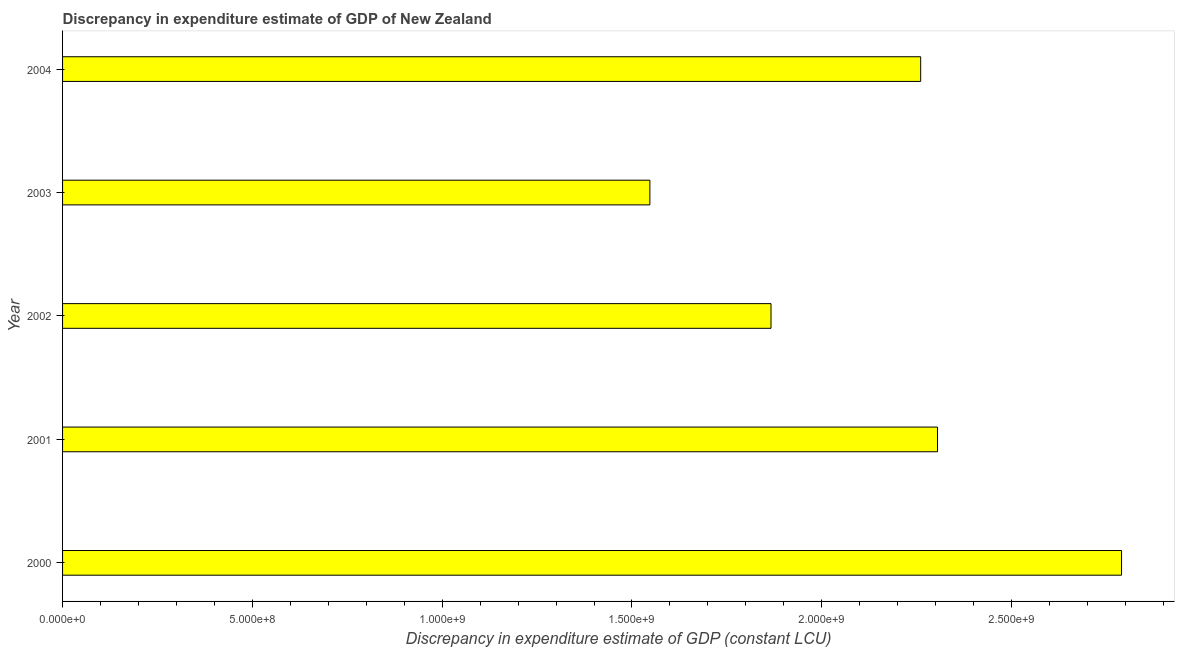Does the graph contain grids?
Make the answer very short. No. What is the title of the graph?
Your answer should be compact. Discrepancy in expenditure estimate of GDP of New Zealand. What is the label or title of the X-axis?
Ensure brevity in your answer.  Discrepancy in expenditure estimate of GDP (constant LCU). What is the label or title of the Y-axis?
Your answer should be very brief. Year. What is the discrepancy in expenditure estimate of gdp in 2001?
Offer a very short reply. 2.30e+09. Across all years, what is the maximum discrepancy in expenditure estimate of gdp?
Provide a succinct answer. 2.79e+09. Across all years, what is the minimum discrepancy in expenditure estimate of gdp?
Ensure brevity in your answer.  1.55e+09. In which year was the discrepancy in expenditure estimate of gdp minimum?
Keep it short and to the point. 2003. What is the sum of the discrepancy in expenditure estimate of gdp?
Offer a terse response. 1.08e+1. What is the difference between the discrepancy in expenditure estimate of gdp in 2000 and 2003?
Your response must be concise. 1.24e+09. What is the average discrepancy in expenditure estimate of gdp per year?
Your answer should be compact. 2.15e+09. What is the median discrepancy in expenditure estimate of gdp?
Provide a succinct answer. 2.26e+09. What is the ratio of the discrepancy in expenditure estimate of gdp in 2001 to that in 2004?
Give a very brief answer. 1.02. Is the discrepancy in expenditure estimate of gdp in 2002 less than that in 2004?
Give a very brief answer. Yes. What is the difference between the highest and the second highest discrepancy in expenditure estimate of gdp?
Ensure brevity in your answer.  4.85e+08. Is the sum of the discrepancy in expenditure estimate of gdp in 2002 and 2003 greater than the maximum discrepancy in expenditure estimate of gdp across all years?
Make the answer very short. Yes. What is the difference between the highest and the lowest discrepancy in expenditure estimate of gdp?
Keep it short and to the point. 1.24e+09. What is the difference between two consecutive major ticks on the X-axis?
Provide a succinct answer. 5.00e+08. Are the values on the major ticks of X-axis written in scientific E-notation?
Keep it short and to the point. Yes. What is the Discrepancy in expenditure estimate of GDP (constant LCU) in 2000?
Ensure brevity in your answer.  2.79e+09. What is the Discrepancy in expenditure estimate of GDP (constant LCU) in 2001?
Ensure brevity in your answer.  2.30e+09. What is the Discrepancy in expenditure estimate of GDP (constant LCU) in 2002?
Keep it short and to the point. 1.87e+09. What is the Discrepancy in expenditure estimate of GDP (constant LCU) of 2003?
Your response must be concise. 1.55e+09. What is the Discrepancy in expenditure estimate of GDP (constant LCU) in 2004?
Offer a very short reply. 2.26e+09. What is the difference between the Discrepancy in expenditure estimate of GDP (constant LCU) in 2000 and 2001?
Give a very brief answer. 4.85e+08. What is the difference between the Discrepancy in expenditure estimate of GDP (constant LCU) in 2000 and 2002?
Give a very brief answer. 9.23e+08. What is the difference between the Discrepancy in expenditure estimate of GDP (constant LCU) in 2000 and 2003?
Give a very brief answer. 1.24e+09. What is the difference between the Discrepancy in expenditure estimate of GDP (constant LCU) in 2000 and 2004?
Make the answer very short. 5.29e+08. What is the difference between the Discrepancy in expenditure estimate of GDP (constant LCU) in 2001 and 2002?
Give a very brief answer. 4.39e+08. What is the difference between the Discrepancy in expenditure estimate of GDP (constant LCU) in 2001 and 2003?
Offer a very short reply. 7.58e+08. What is the difference between the Discrepancy in expenditure estimate of GDP (constant LCU) in 2001 and 2004?
Your response must be concise. 4.44e+07. What is the difference between the Discrepancy in expenditure estimate of GDP (constant LCU) in 2002 and 2003?
Offer a terse response. 3.19e+08. What is the difference between the Discrepancy in expenditure estimate of GDP (constant LCU) in 2002 and 2004?
Offer a terse response. -3.94e+08. What is the difference between the Discrepancy in expenditure estimate of GDP (constant LCU) in 2003 and 2004?
Make the answer very short. -7.13e+08. What is the ratio of the Discrepancy in expenditure estimate of GDP (constant LCU) in 2000 to that in 2001?
Your answer should be very brief. 1.21. What is the ratio of the Discrepancy in expenditure estimate of GDP (constant LCU) in 2000 to that in 2002?
Offer a very short reply. 1.5. What is the ratio of the Discrepancy in expenditure estimate of GDP (constant LCU) in 2000 to that in 2003?
Your response must be concise. 1.8. What is the ratio of the Discrepancy in expenditure estimate of GDP (constant LCU) in 2000 to that in 2004?
Keep it short and to the point. 1.23. What is the ratio of the Discrepancy in expenditure estimate of GDP (constant LCU) in 2001 to that in 2002?
Offer a terse response. 1.24. What is the ratio of the Discrepancy in expenditure estimate of GDP (constant LCU) in 2001 to that in 2003?
Keep it short and to the point. 1.49. What is the ratio of the Discrepancy in expenditure estimate of GDP (constant LCU) in 2001 to that in 2004?
Provide a succinct answer. 1.02. What is the ratio of the Discrepancy in expenditure estimate of GDP (constant LCU) in 2002 to that in 2003?
Keep it short and to the point. 1.21. What is the ratio of the Discrepancy in expenditure estimate of GDP (constant LCU) in 2002 to that in 2004?
Your response must be concise. 0.83. What is the ratio of the Discrepancy in expenditure estimate of GDP (constant LCU) in 2003 to that in 2004?
Offer a very short reply. 0.68. 